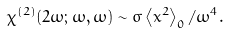Convert formula to latex. <formula><loc_0><loc_0><loc_500><loc_500>\chi ^ { ( 2 ) } ( 2 \omega ; \omega , \omega ) \sim \sigma \left \langle x ^ { 2 } \right \rangle _ { 0 } / \omega ^ { 4 } .</formula> 